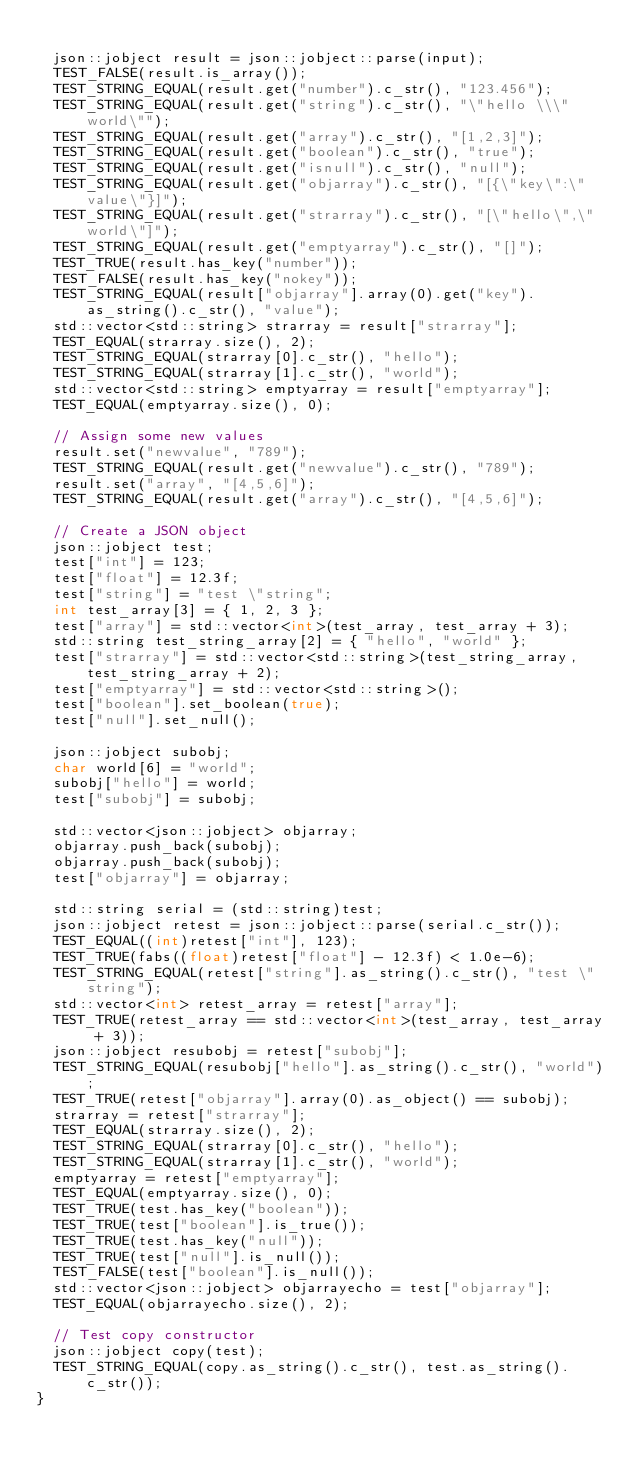<code> <loc_0><loc_0><loc_500><loc_500><_C++_>
	json::jobject result = json::jobject::parse(input);
	TEST_FALSE(result.is_array());
	TEST_STRING_EQUAL(result.get("number").c_str(), "123.456");
	TEST_STRING_EQUAL(result.get("string").c_str(), "\"hello \\\" world\"");
	TEST_STRING_EQUAL(result.get("array").c_str(), "[1,2,3]");
	TEST_STRING_EQUAL(result.get("boolean").c_str(), "true");
	TEST_STRING_EQUAL(result.get("isnull").c_str(), "null");
	TEST_STRING_EQUAL(result.get("objarray").c_str(), "[{\"key\":\"value\"}]");
	TEST_STRING_EQUAL(result.get("strarray").c_str(), "[\"hello\",\"world\"]");
	TEST_STRING_EQUAL(result.get("emptyarray").c_str(), "[]");
	TEST_TRUE(result.has_key("number"));
	TEST_FALSE(result.has_key("nokey"));
	TEST_STRING_EQUAL(result["objarray"].array(0).get("key").as_string().c_str(), "value");
	std::vector<std::string> strarray = result["strarray"];
	TEST_EQUAL(strarray.size(), 2);
	TEST_STRING_EQUAL(strarray[0].c_str(), "hello");
	TEST_STRING_EQUAL(strarray[1].c_str(), "world");
	std::vector<std::string> emptyarray = result["emptyarray"];
	TEST_EQUAL(emptyarray.size(), 0);

	// Assign some new values
	result.set("newvalue", "789");
	TEST_STRING_EQUAL(result.get("newvalue").c_str(), "789");
	result.set("array", "[4,5,6]");
	TEST_STRING_EQUAL(result.get("array").c_str(), "[4,5,6]");

	// Create a JSON object
	json::jobject test;
	test["int"] = 123;
	test["float"] = 12.3f;
	test["string"] = "test \"string";
	int test_array[3] = { 1, 2, 3 };
	test["array"] = std::vector<int>(test_array, test_array + 3);
	std::string test_string_array[2] = { "hello", "world" };
	test["strarray"] = std::vector<std::string>(test_string_array, test_string_array + 2);
	test["emptyarray"] = std::vector<std::string>();
	test["boolean"].set_boolean(true);
	test["null"].set_null();

	json::jobject subobj;
	char world[6] = "world";
	subobj["hello"] = world;
	test["subobj"] = subobj;

	std::vector<json::jobject> objarray;
	objarray.push_back(subobj);
	objarray.push_back(subobj);
	test["objarray"] = objarray;

	std::string serial = (std::string)test;
	json::jobject retest = json::jobject::parse(serial.c_str());
	TEST_EQUAL((int)retest["int"], 123);
	TEST_TRUE(fabs((float)retest["float"] - 12.3f) < 1.0e-6);
	TEST_STRING_EQUAL(retest["string"].as_string().c_str(), "test \"string");
	std::vector<int> retest_array = retest["array"];
	TEST_TRUE(retest_array == std::vector<int>(test_array, test_array + 3));
	json::jobject resubobj = retest["subobj"];
	TEST_STRING_EQUAL(resubobj["hello"].as_string().c_str(), "world");
	TEST_TRUE(retest["objarray"].array(0).as_object() == subobj);
	strarray = retest["strarray"];
	TEST_EQUAL(strarray.size(), 2);
	TEST_STRING_EQUAL(strarray[0].c_str(), "hello");
	TEST_STRING_EQUAL(strarray[1].c_str(), "world");
	emptyarray = retest["emptyarray"];
	TEST_EQUAL(emptyarray.size(), 0);
	TEST_TRUE(test.has_key("boolean"));
	TEST_TRUE(test["boolean"].is_true());
	TEST_TRUE(test.has_key("null"));
	TEST_TRUE(test["null"].is_null());
	TEST_FALSE(test["boolean"].is_null());
	std::vector<json::jobject> objarrayecho = test["objarray"];
	TEST_EQUAL(objarrayecho.size(), 2);

	// Test copy constructor
	json::jobject copy(test);
	TEST_STRING_EQUAL(copy.as_string().c_str(), test.as_string().c_str());
}</code> 